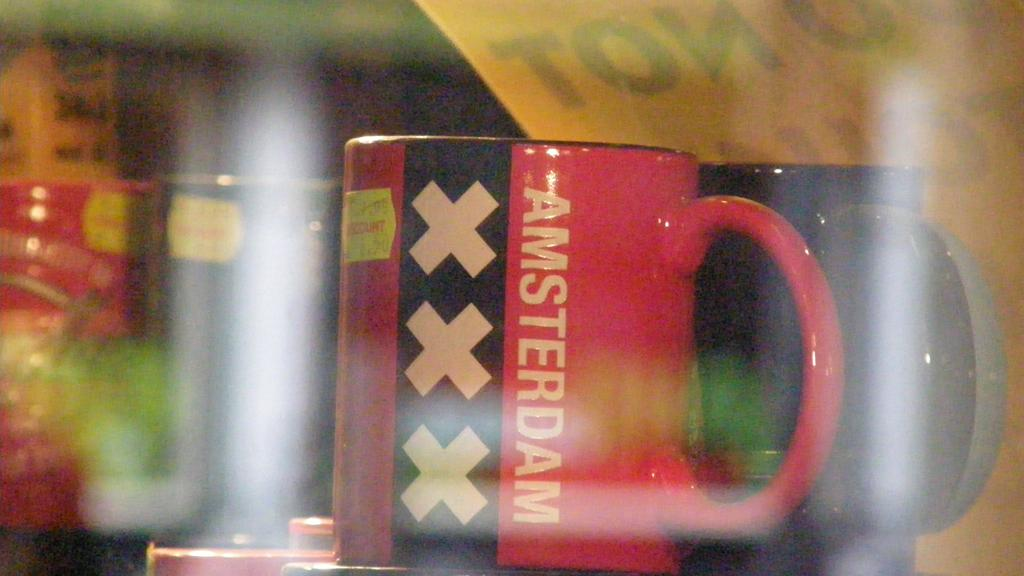<image>
Provide a brief description of the given image. A red and black coffee cup is printed with the word AMSTERDAM. 